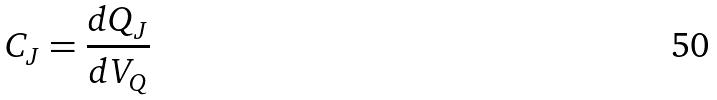<formula> <loc_0><loc_0><loc_500><loc_500>C _ { J } = \frac { d Q _ { J } } { d V _ { Q } }</formula> 